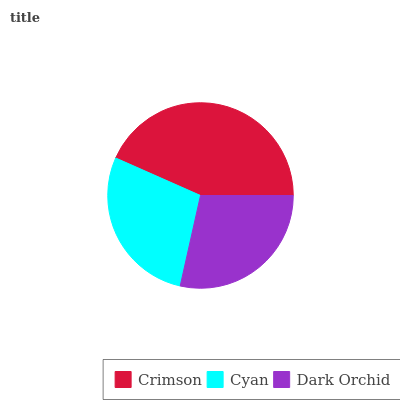Is Cyan the minimum?
Answer yes or no. Yes. Is Crimson the maximum?
Answer yes or no. Yes. Is Dark Orchid the minimum?
Answer yes or no. No. Is Dark Orchid the maximum?
Answer yes or no. No. Is Dark Orchid greater than Cyan?
Answer yes or no. Yes. Is Cyan less than Dark Orchid?
Answer yes or no. Yes. Is Cyan greater than Dark Orchid?
Answer yes or no. No. Is Dark Orchid less than Cyan?
Answer yes or no. No. Is Dark Orchid the high median?
Answer yes or no. Yes. Is Dark Orchid the low median?
Answer yes or no. Yes. Is Crimson the high median?
Answer yes or no. No. Is Crimson the low median?
Answer yes or no. No. 